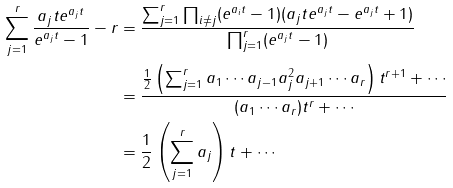Convert formula to latex. <formula><loc_0><loc_0><loc_500><loc_500>\sum _ { j = 1 } ^ { r } \frac { a _ { j } t e ^ { a _ { j } t } } { e ^ { a _ { j } t } - 1 } - r & = \frac { \sum _ { j = 1 } ^ { r } \prod _ { i \ne j } ( e ^ { a _ { i } t } - 1 ) ( a _ { j } t e ^ { a _ { j } t } - e ^ { a _ { j } t } + 1 ) } { \prod _ { j = 1 } ^ { r } ( e ^ { a _ { j } t } - 1 ) } \\ & = \frac { \frac { 1 } { 2 } \left ( \sum _ { j = 1 } ^ { r } a _ { 1 } \cdots a _ { j - 1 } a _ { j } ^ { 2 } a _ { j + 1 } \cdots a _ { r } \right ) t ^ { r + 1 } + \cdots } { ( a _ { 1 } \cdots a _ { r } ) t ^ { r } + \cdots } \\ & = \frac { 1 } { 2 } \left ( \sum _ { j = 1 } ^ { r } a _ { j } \right ) t + \cdots</formula> 